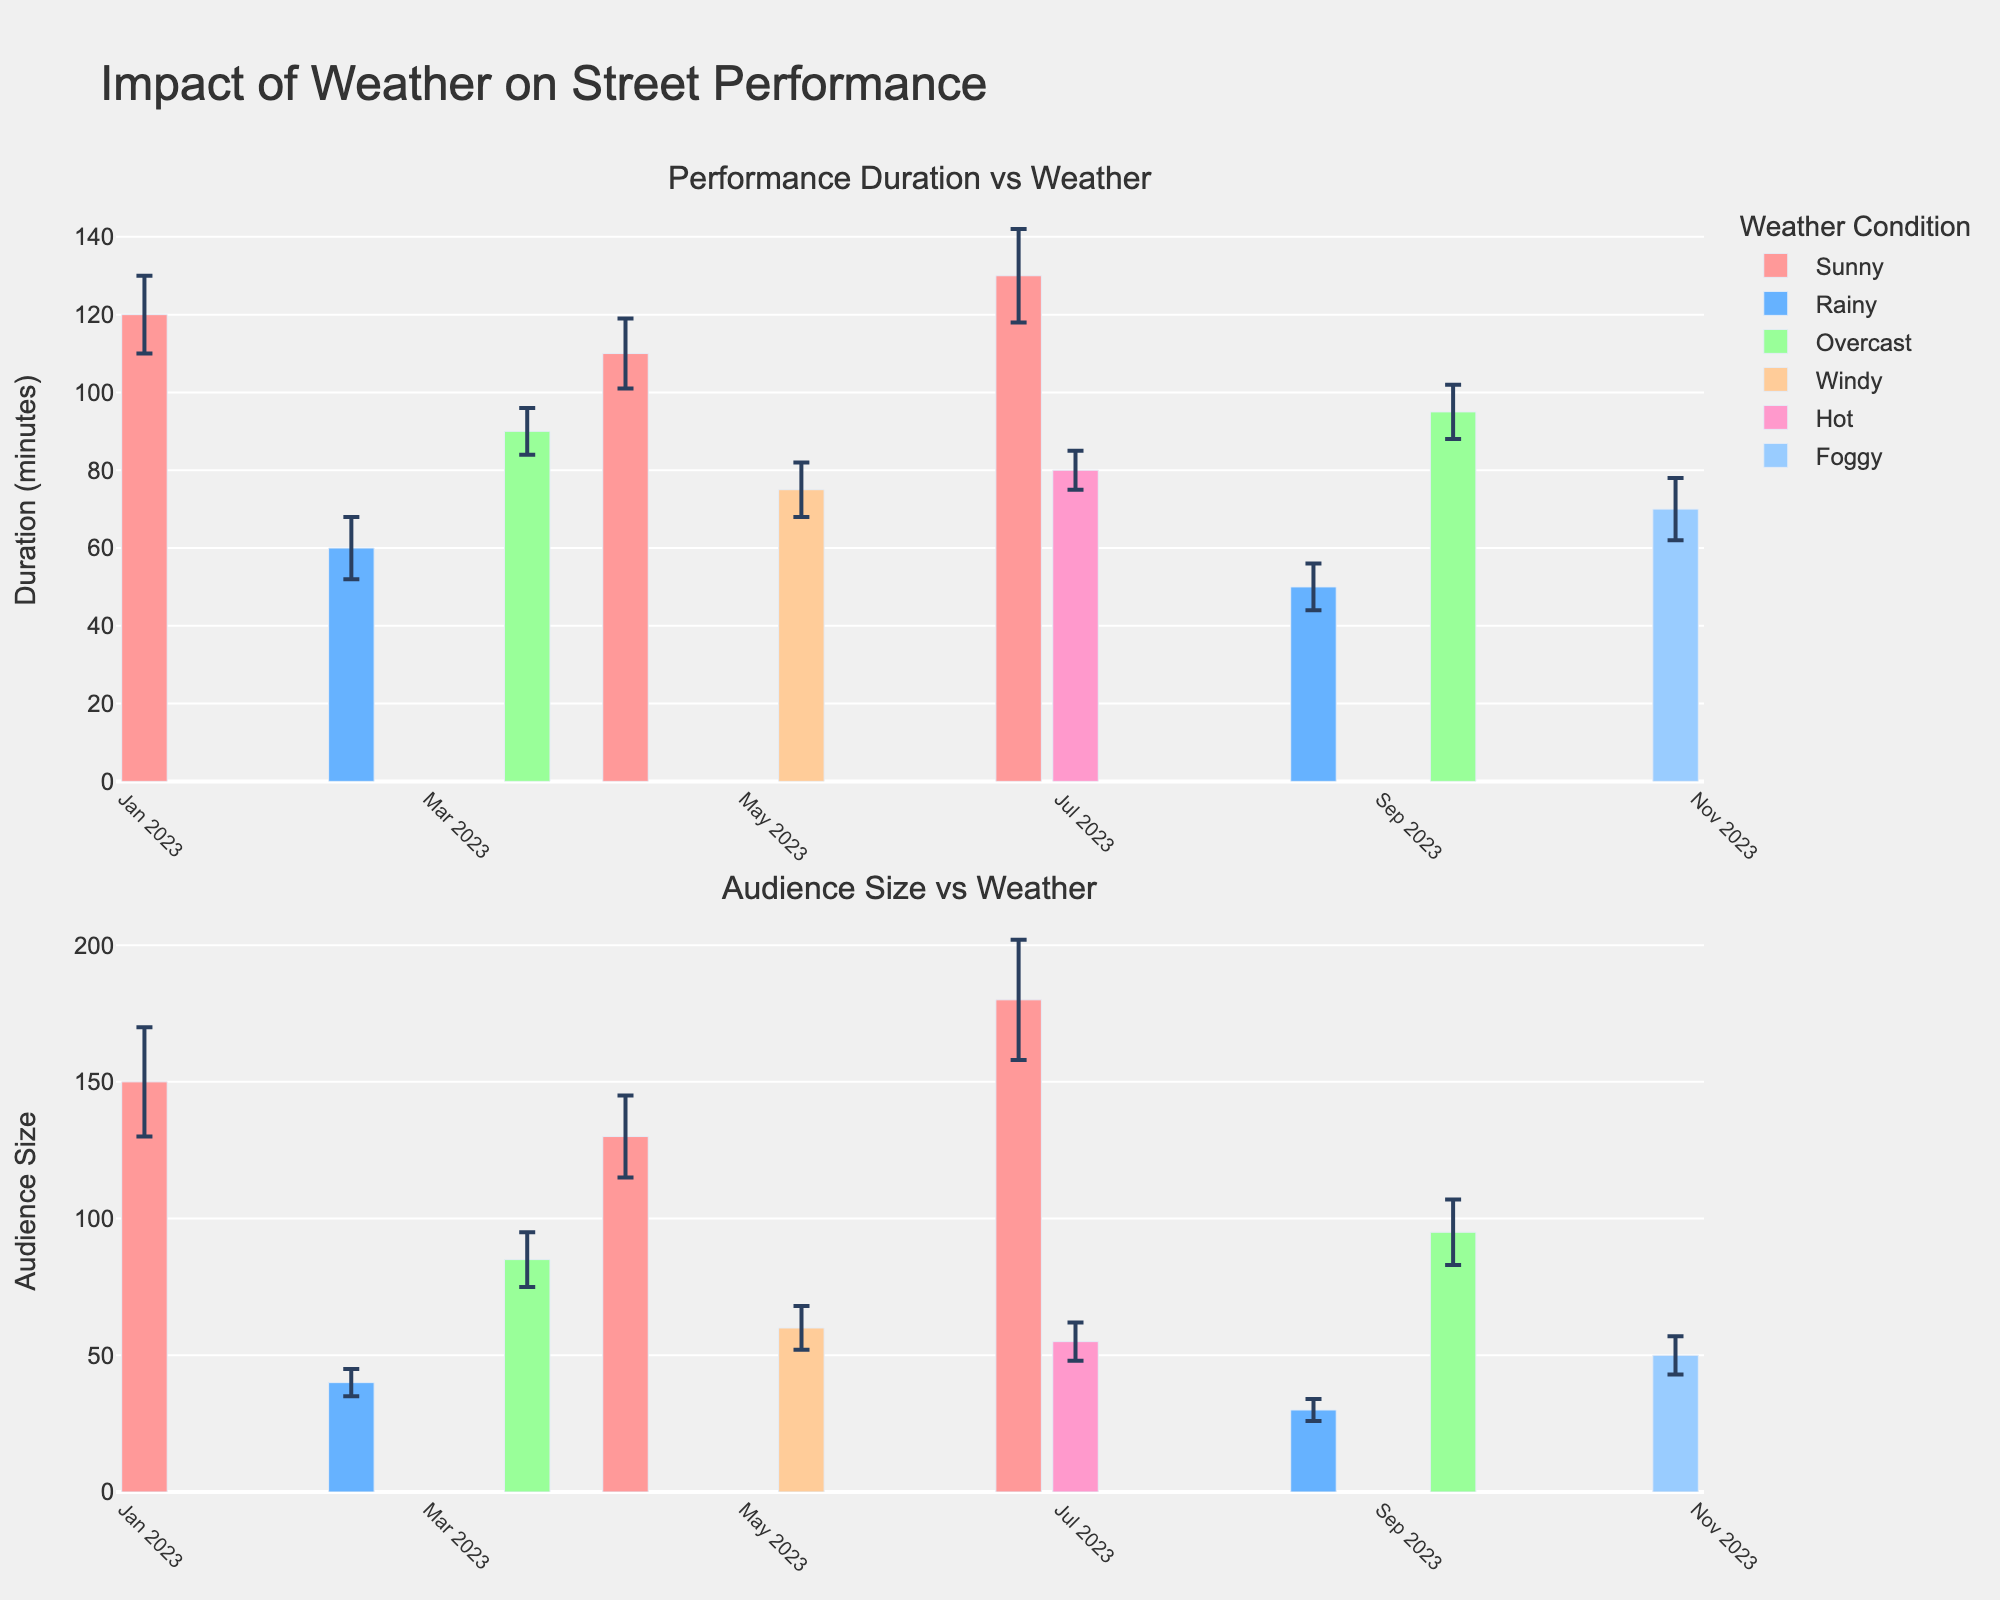What is the title of the figure? The title is displayed at the top of the figure. It provides an overview of what the figure is about.
Answer: Impact of Weather on Street Performance Which weather condition appears the most in the first plot? By counting the number of bars for each weather condition in the first plot, the condition with the most bars is easily identified.
Answer: Sunny What is the performance duration on June 23 in Bryant Park? Locate the bar for June 23 in Bryant Park on the first plot, and observe its height, which represents the performance duration.
Answer: 130 minutes Which event had the smallest audience size? In the second plot, find the shortest bar, which corresponds to the smallest audience size. Check the associated date and location for that bar.
Answer: August 19 in Tompkins Square Park Compare the performance duration on sunny days to rainy days. Which is generally longer? Check the heights of the bars corresponding to sunny and rainy days in the first plot and compare them.
Answer: Sunny days generally have longer performance durations What is the average audience size for performances conducted during overcast weather? Identify the bars related to overcast weather in the second plot, sum their heights (audience sizes), and divide by the number of overcast events.
Answer: (85 + 95) / 2 = 90 Which performance location had the highest audience size, and what was its size? In the second plot, identify the tallest bar and read the audience size and location associated with it.
Answer: Bryant Park with an audience size of 180 What is the standard deviation of the performance duration on April 8 in Brooklyn Promenade? Look at the error bar (vertical line extending from the top of the bar) on April 8 in the first plot, it represents the standard deviation.
Answer: 9 During which weather condition did the Brooklyn Promenade event take place, and how does this condition compare to others in terms of average audience size? First, identify the weather condition for Brooklyn Promenade from the first plot, then examine the audience sizes for events under this condition in the second plot and compare their average to others.
Answer: Sunny; on average, it has a larger audience size 